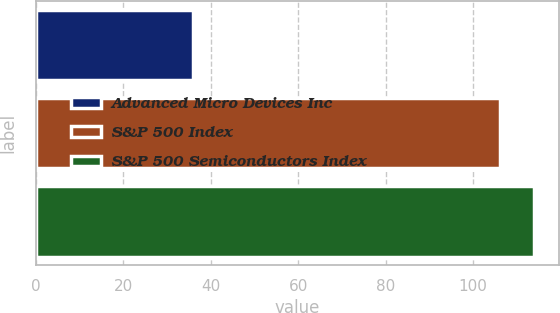Convert chart to OTSL. <chart><loc_0><loc_0><loc_500><loc_500><bar_chart><fcel>Advanced Micro Devices Inc<fcel>S&P 500 Index<fcel>S&P 500 Semiconductors Index<nl><fcel>35.97<fcel>106.22<fcel>113.86<nl></chart> 